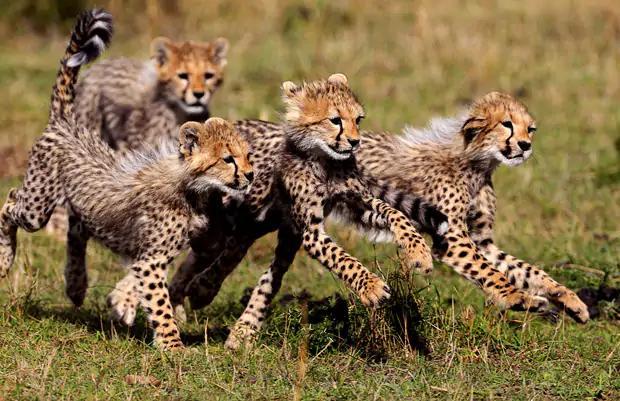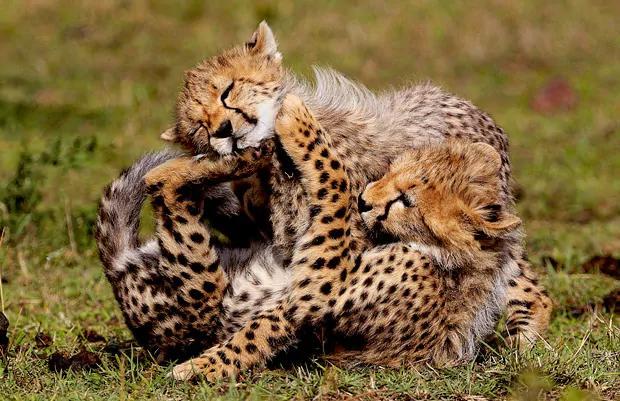The first image is the image on the left, the second image is the image on the right. For the images displayed, is the sentence "One image has a wild cat in the middle of pouncing onto another wild cat." factually correct? Answer yes or no. No. The first image is the image on the left, the second image is the image on the right. Examine the images to the left and right. Is the description "There are at most 4 cheetahs." accurate? Answer yes or no. No. 